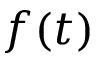Convert formula to latex. <formula><loc_0><loc_0><loc_500><loc_500>f ( t )</formula> 